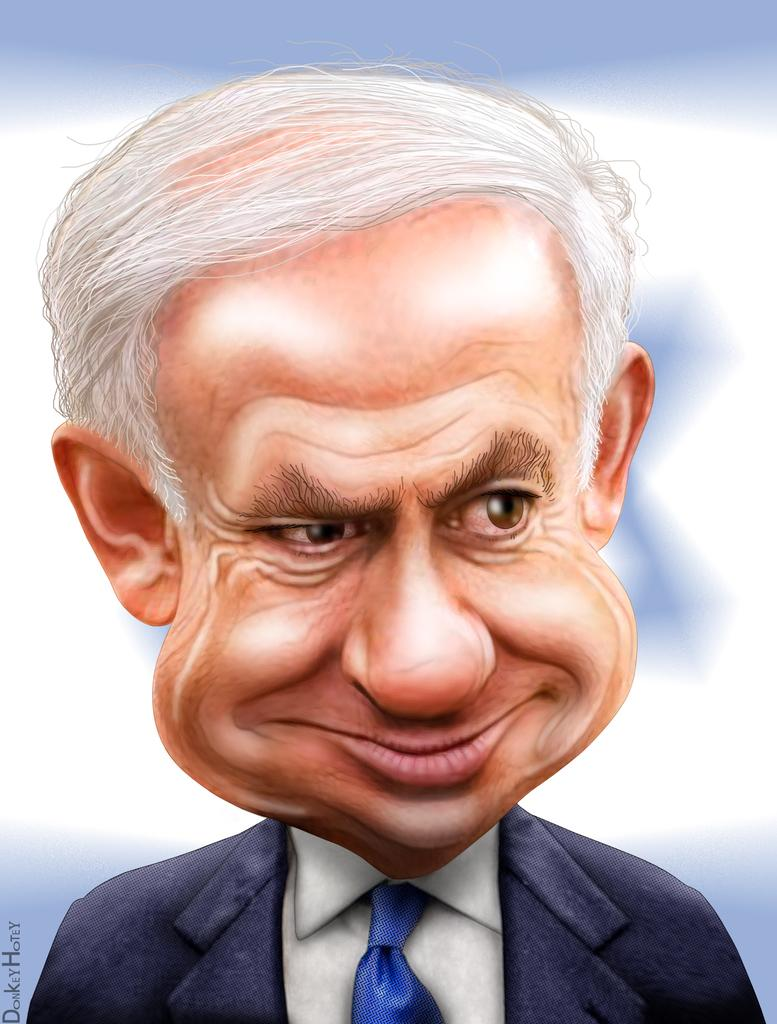What type of image is this? The image is an edited image of a person. How is the background of the image depicted? The background of the image is blurred. Is there any text present in the image? Yes, there is text in the bottom left of the image. How many wheels are visible on the van in the image? There is no van present in the image, so no wheels can be seen. What type of discovery is being made in the image? There is no indication of a discovery being made in the image. 